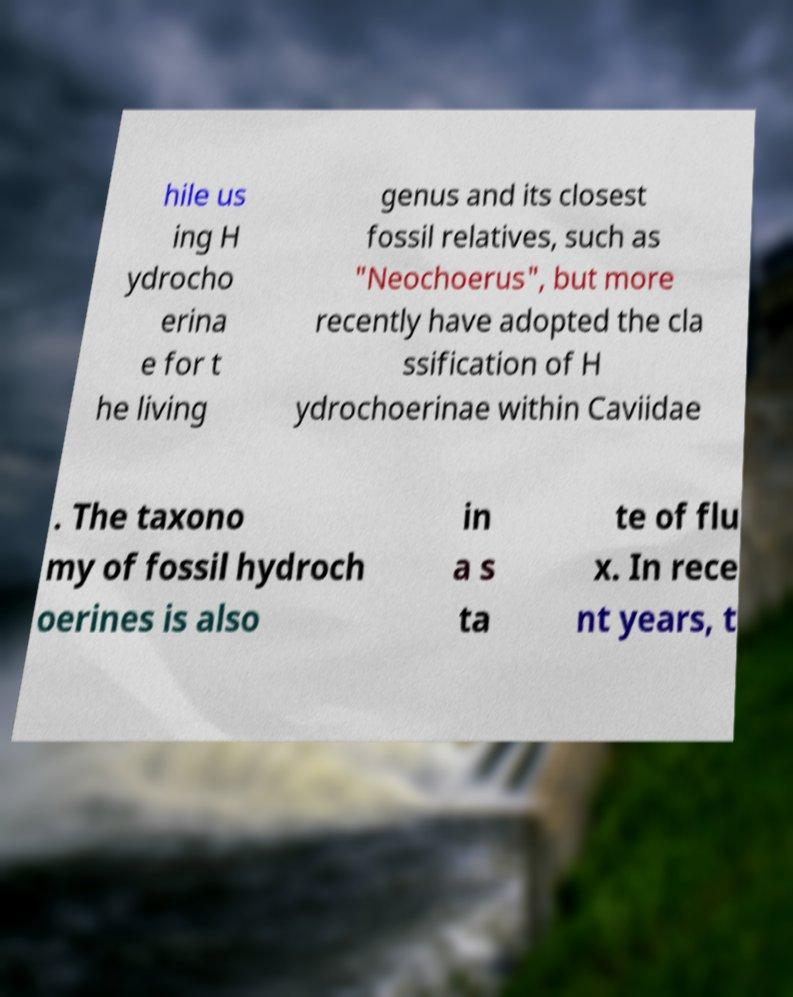Please identify and transcribe the text found in this image. hile us ing H ydrocho erina e for t he living genus and its closest fossil relatives, such as "Neochoerus", but more recently have adopted the cla ssification of H ydrochoerinae within Caviidae . The taxono my of fossil hydroch oerines is also in a s ta te of flu x. In rece nt years, t 